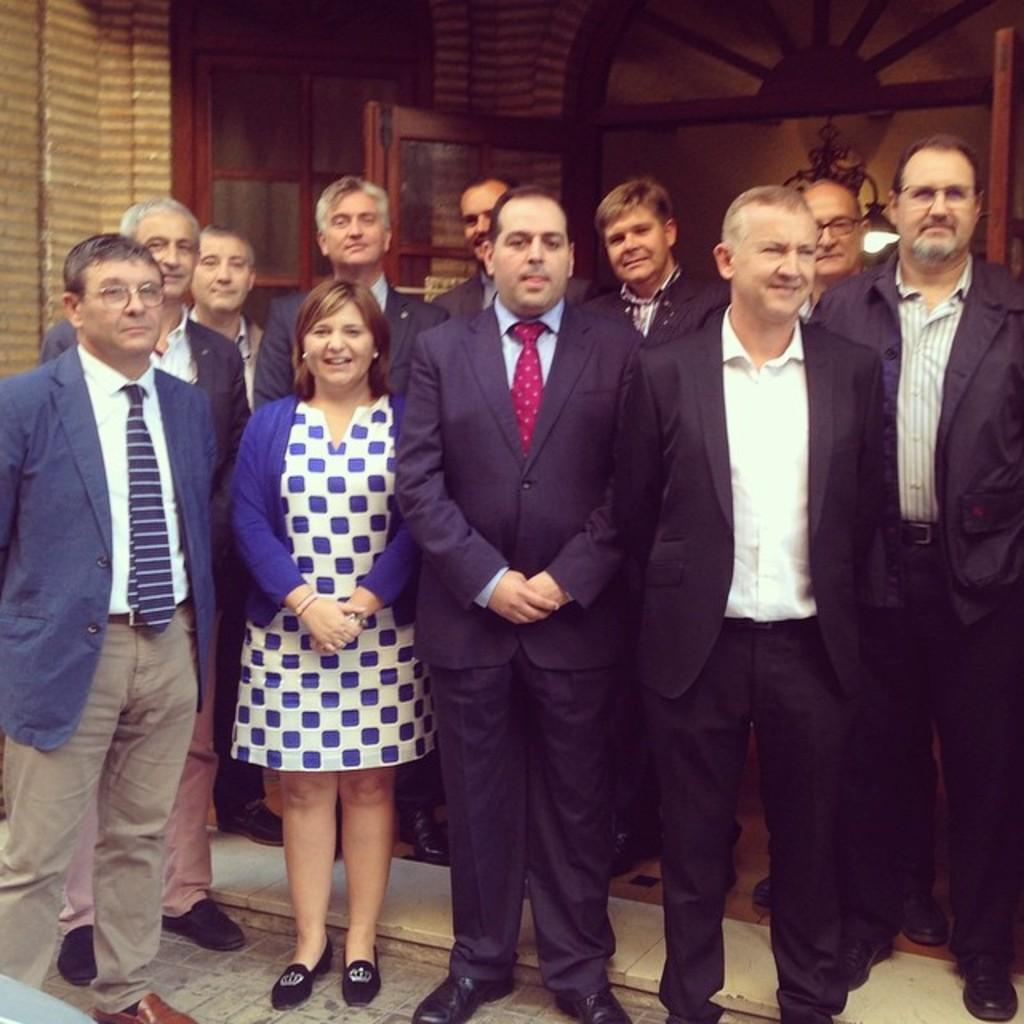What are the people in the image doing? The people in the image are standing. Where are the people standing? The people are standing on the ground. What can be seen on the wall in the image? There is a window and a door in the wall. What color is the hair of the person standing next to the door? There is no information about the color of anyone's hair in the image, as it is not mentioned in the provided facts. 